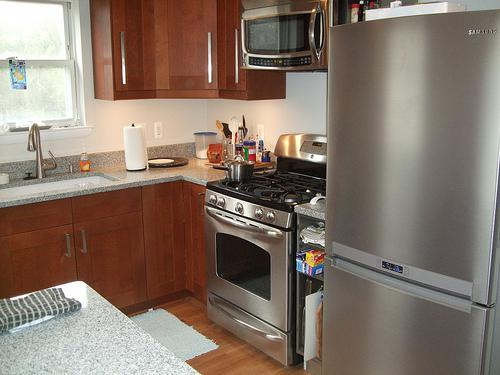Question: what color is the dish towel?
Choices:
A. White and blue.
B. Blue and yellow.
C. White and pink.
D. Green and white.
Answer with the letter. Answer: D Question: how many appliances are visible?
Choices:
A. One.
B. Two.
C. Four.
D. Three.
Answer with the letter. Answer: D Question: what is on top of the stove?
Choices:
A. Kettle.
B. A Pan boiling water.
C. Lobster pot.
D. A pot.
Answer with the letter. Answer: D Question: how many rolls of paper towels are visible?
Choices:
A. One.
B. None.
C. Two.
D. Three.
Answer with the letter. Answer: A Question: where is the microwave?
Choices:
A. In kitchen.
B. Above the stove.
C. Under the counter.
D. On a portable cart.
Answer with the letter. Answer: B Question: what color are the cupboards?
Choices:
A. Blue.
B. Brown.
C. Black.
D. Yellow.
Answer with the letter. Answer: B 